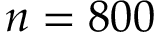Convert formula to latex. <formula><loc_0><loc_0><loc_500><loc_500>n = 8 0 0</formula> 